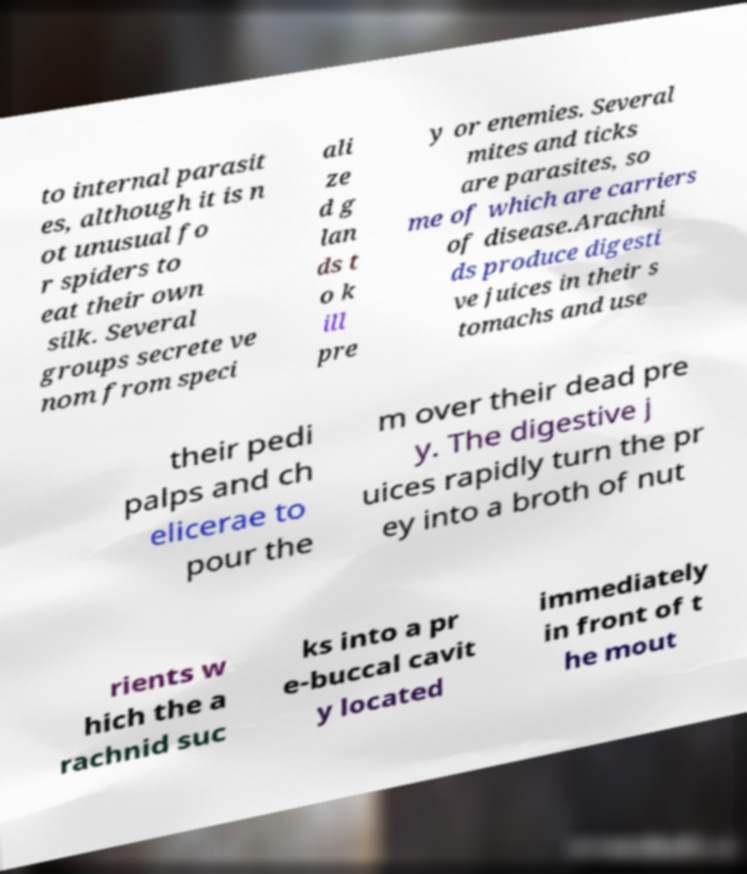Can you accurately transcribe the text from the provided image for me? to internal parasit es, although it is n ot unusual fo r spiders to eat their own silk. Several groups secrete ve nom from speci ali ze d g lan ds t o k ill pre y or enemies. Several mites and ticks are parasites, so me of which are carriers of disease.Arachni ds produce digesti ve juices in their s tomachs and use their pedi palps and ch elicerae to pour the m over their dead pre y. The digestive j uices rapidly turn the pr ey into a broth of nut rients w hich the a rachnid suc ks into a pr e-buccal cavit y located immediately in front of t he mout 